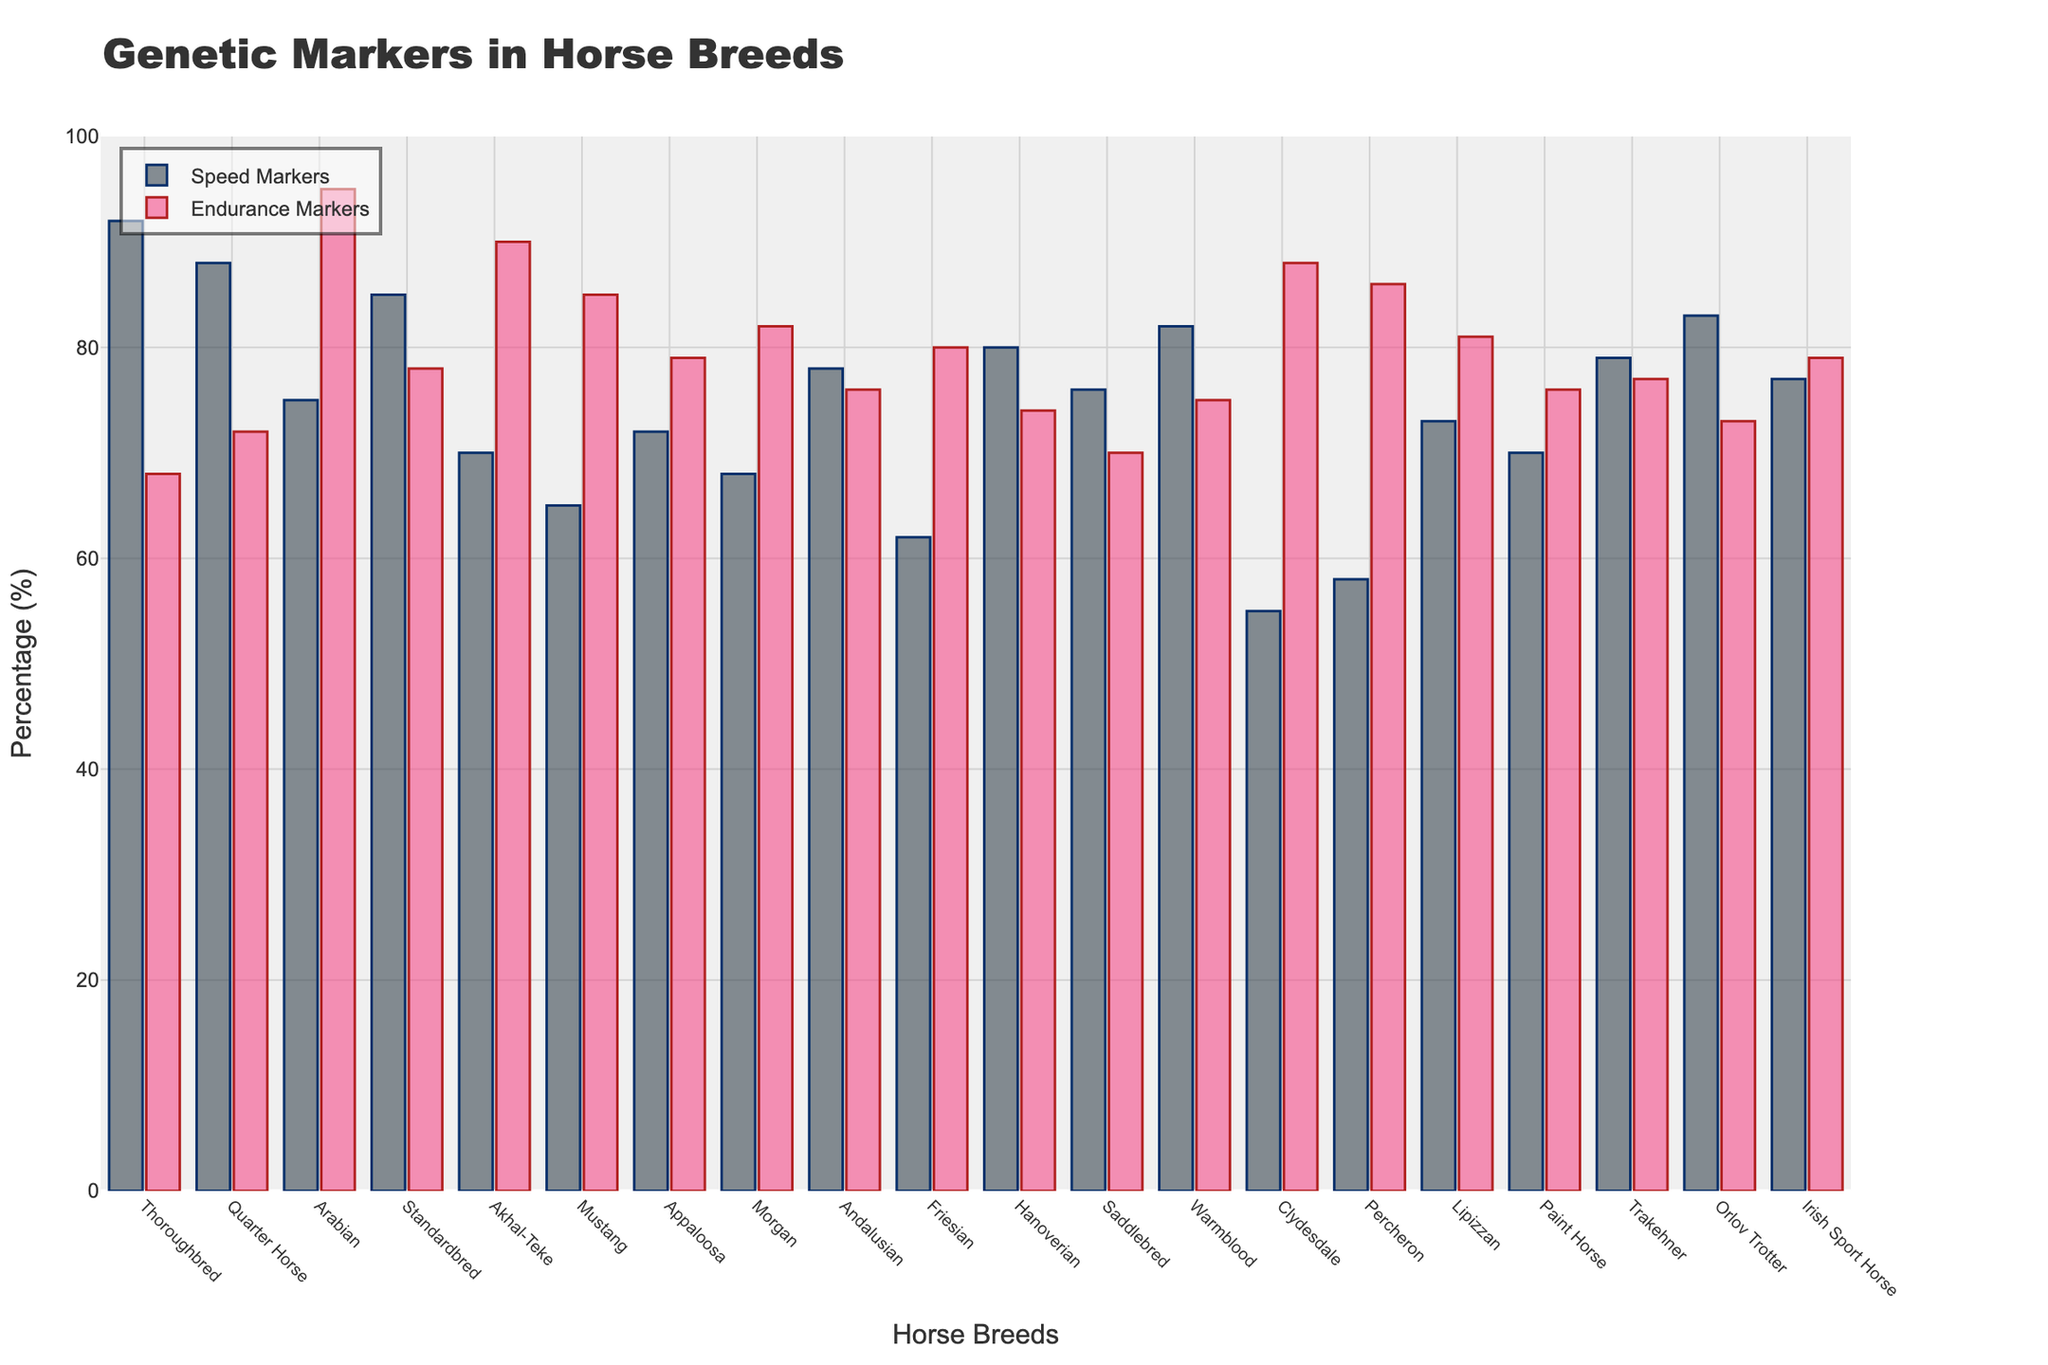What's the breed with the highest percentage of speed markers? By observing the heights of the bars representing Speed Markers, Thoroughbred has the tallest bar indicating the highest percentage of speed markers at 92%.
Answer: Thoroughbred What's the difference in speed markers between Thoroughbred and Quarter Horse? The percentage of speed markers for Thoroughbred is 92% and for Quarter Horse is 88%. The difference is calculated as 92% - 88% = 4%.
Answer: 4% Which breed has the lowest percentage of endurance markers? By inspecting the heights of the bars for Endurance Markers, Thoroughbred has the shortest bar at 68%.
Answer: Thoroughbred Which breed has higher endurance markers, Morgan or Friesian? Looking at the bars representing the Endurance Markers, Morgan has 82% while Friesian has 80%. Thus, Morgan has higher endurance markers.
Answer: Morgan What is the sum of speed markers percentages for Morgan and Appaloosa? Adding the speed markers percentages for Morgan (68%) and Appaloosa (72%) gives us 68% + 72% = 140%.
Answer: 140% Which breed has a closer balance between speed and endurance markers, Arabian or Clydesdale? For Arabian, the speed markers are 75% and the endurance markers are 95%, giving a difference of 20% (95% - 75%). For Clydesdale, speed markers are 55% and endurance markers are 88%, giving a difference of 33% (88% - 55%). A smaller difference indicates a closer balance; hence, Arabian has a closer balance.
Answer: Arabian For which breed is the percentage of endurance markers higher than speed markers, and by how much? By comparing the heights of the Speed and Endurance Markers bars for each breed, Arabian has 75% (Speed Markers) and 95% (Endurance Markers). The difference is 95% - 75% = 20%.
Answer: Arabian by 20% How does the Paint Horse's speed markers compare with its endurance markers? Paint Horse has 70% for Speed Markers and 76% for Endurance Markers, showing that endurance markers are 6% higher than speed markers (76% - 70%).
Answer: Endurance markers are 6% higher What is the average percentage of endurance markers across all breeds? Summing up all the endurance markers percentages (68, 72, 95, 78, 90, 85, 79, 82, 76, 80, 74, 70, 75, 88, 86, 81, 76, 77, 73, 79) equals 1526%. Dividing by the number of breeds (20) gives an average of 76.3%.
Answer: 76.3% Which breed has a higher percentage of speed markers, Irish Sport Horse or Trakehner? Comparing the heights of the Speed Markers bars, the Irish Sport Horse has 77% and Trakehner has 79%, so Trakehner has a higher percentage.
Answer: Trakehner 